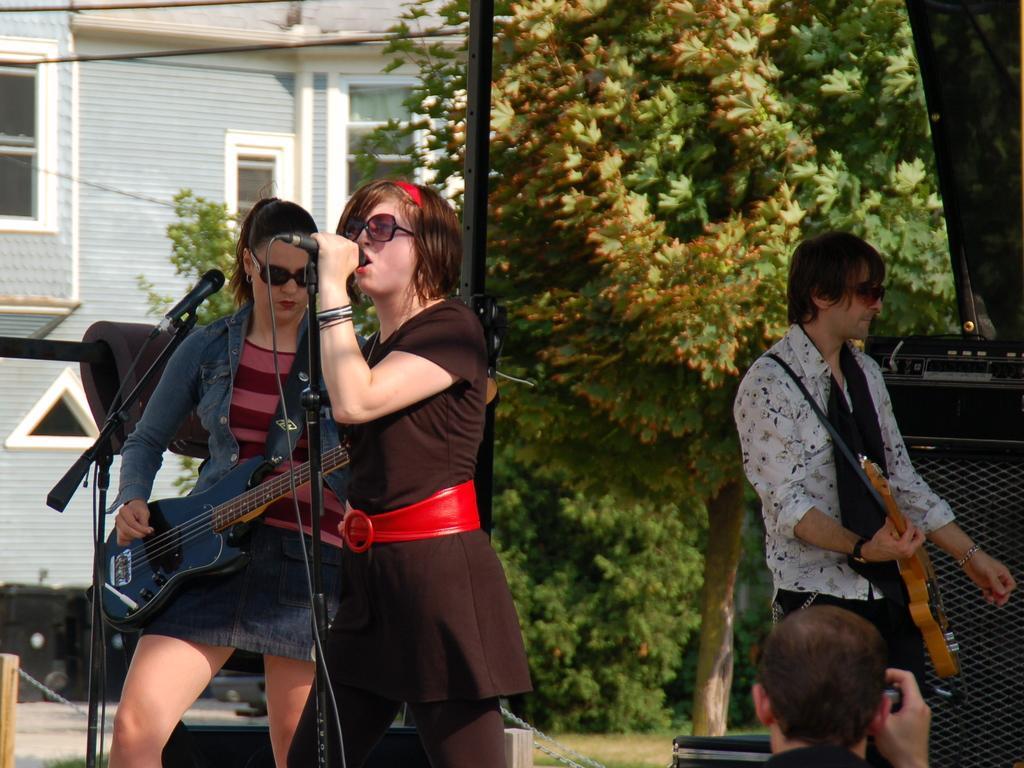Describe this image in one or two sentences. In this image I can see three people who are playing musical instrument and singing song in front of a microphone. In the background I can see there is a house and a tree. 